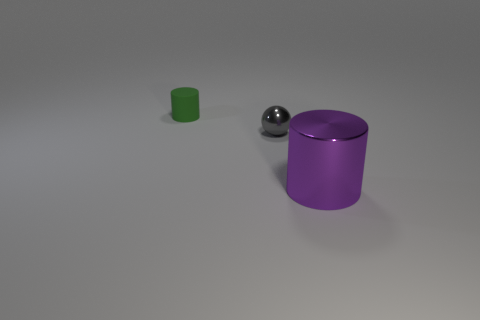Add 3 large purple objects. How many objects exist? 6 Subtract all balls. How many objects are left? 2 Subtract all large things. Subtract all metallic objects. How many objects are left? 0 Add 2 gray metallic things. How many gray metallic things are left? 3 Add 3 big things. How many big things exist? 4 Subtract 0 gray cubes. How many objects are left? 3 